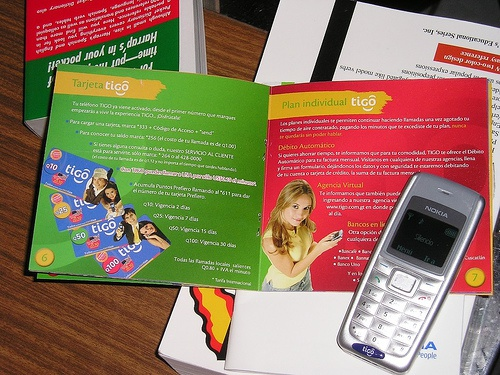Describe the objects in this image and their specific colors. I can see book in maroon, green, brown, and red tones, book in maroon, lightgray, black, darkgray, and gray tones, book in maroon, darkgreen, brown, and lightgray tones, cell phone in maroon, white, darkgray, black, and gray tones, and people in maroon, khaki, tan, and olive tones in this image. 